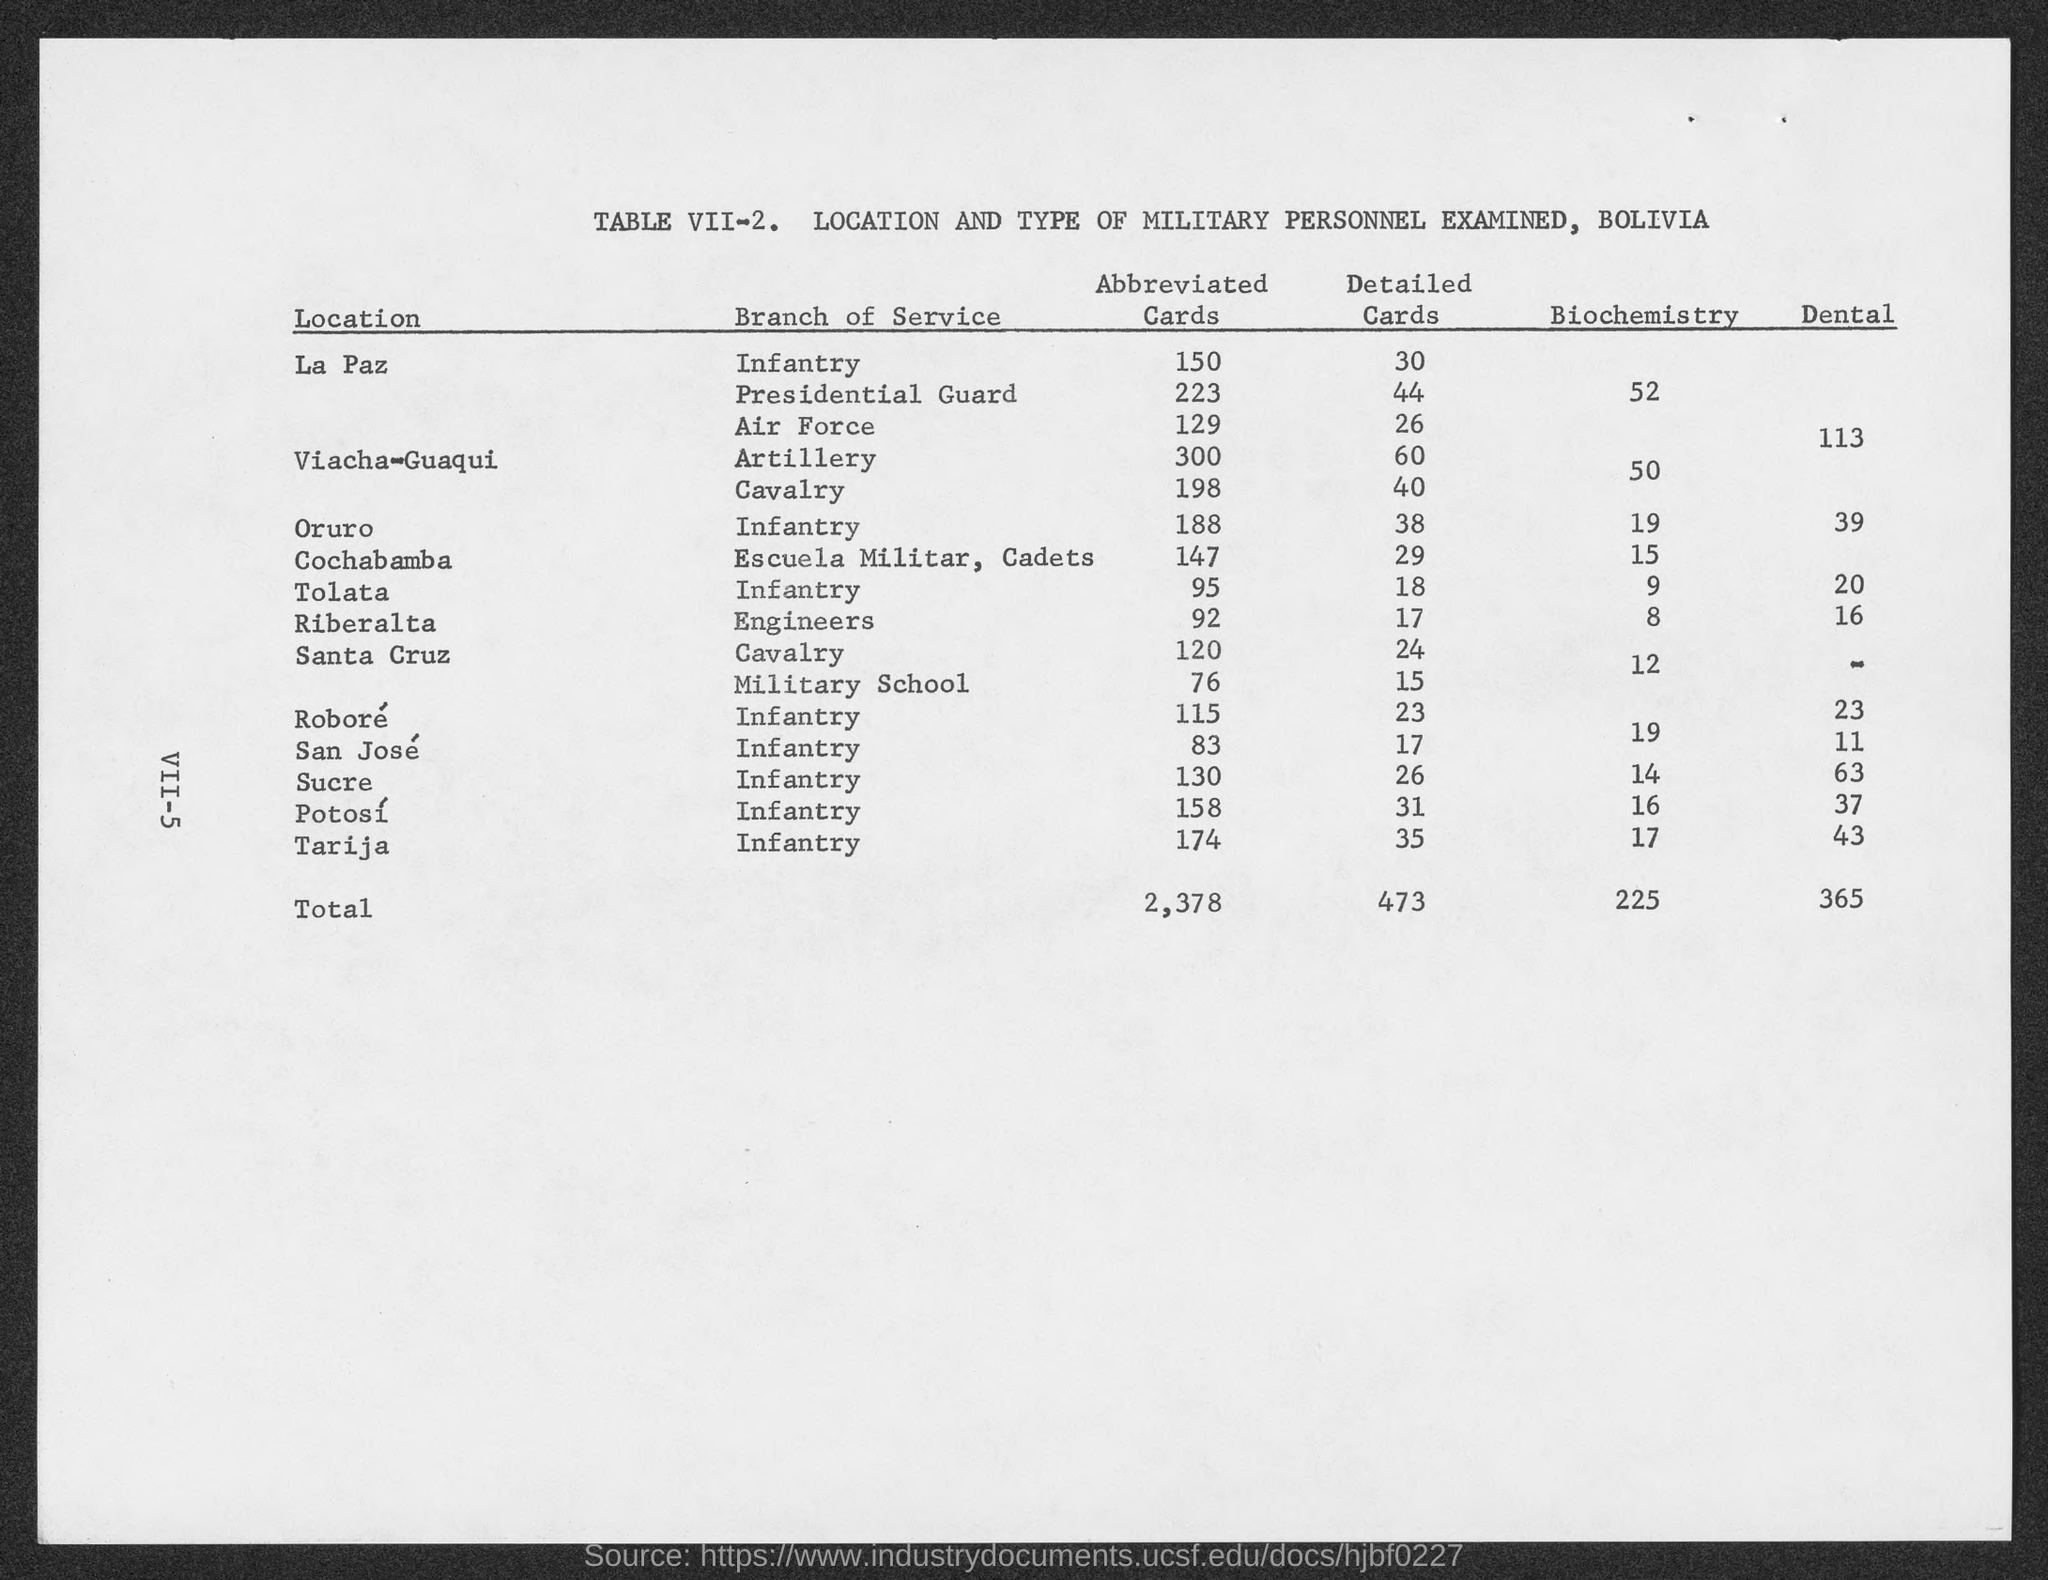Mention a couple of crucial points in this snapshot. The total of dental is 365. The total in Biochemistry is 225. The total number of abbreviated cards is 2,378. In total, there are 473 detailed cards. 